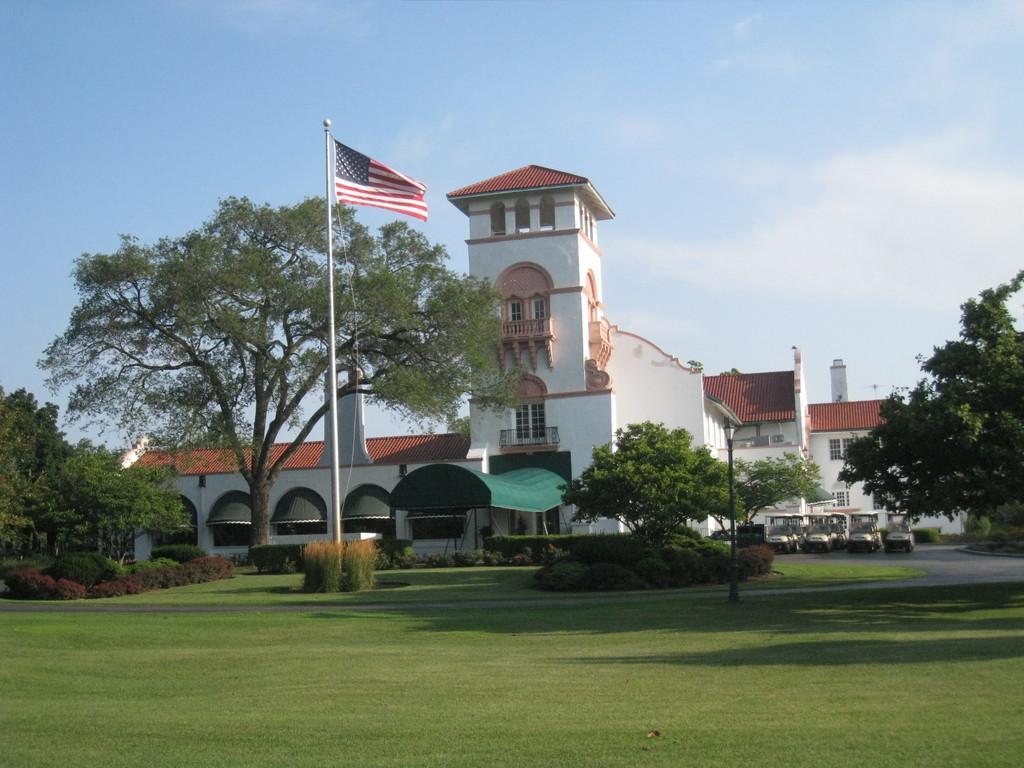Describe this image in one or two sentences. In this image we can see the building, trees, plants, grass, light pole and also the flag. We can also see the vehicles. In the background we can see the sky with some clouds. 